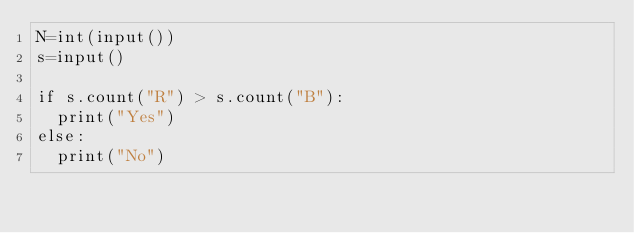<code> <loc_0><loc_0><loc_500><loc_500><_Python_>N=int(input())
s=input()

if s.count("R") > s.count("B"):
  print("Yes")
else:
  print("No")</code> 